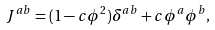<formula> <loc_0><loc_0><loc_500><loc_500>J ^ { a b } = ( 1 - c \phi ^ { 2 } ) \delta ^ { a b } + c \phi ^ { a } \phi ^ { b } ,</formula> 